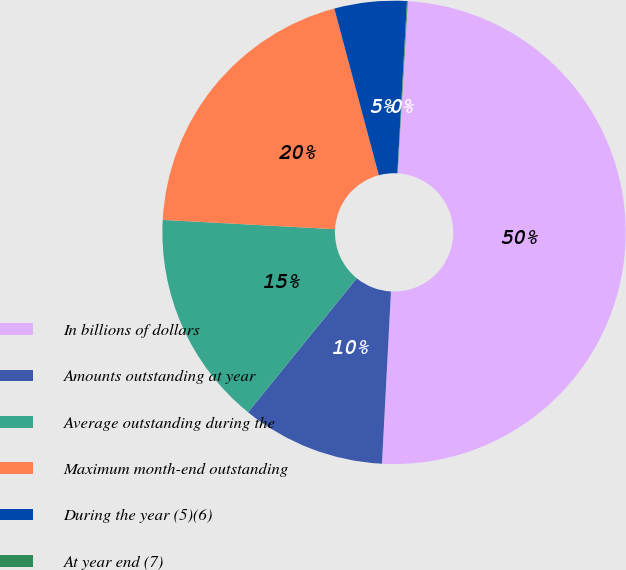Convert chart to OTSL. <chart><loc_0><loc_0><loc_500><loc_500><pie_chart><fcel>In billions of dollars<fcel>Amounts outstanding at year<fcel>Average outstanding during the<fcel>Maximum month-end outstanding<fcel>During the year (5)(6)<fcel>At year end (7)<nl><fcel>49.89%<fcel>10.02%<fcel>15.01%<fcel>19.99%<fcel>5.04%<fcel>0.06%<nl></chart> 